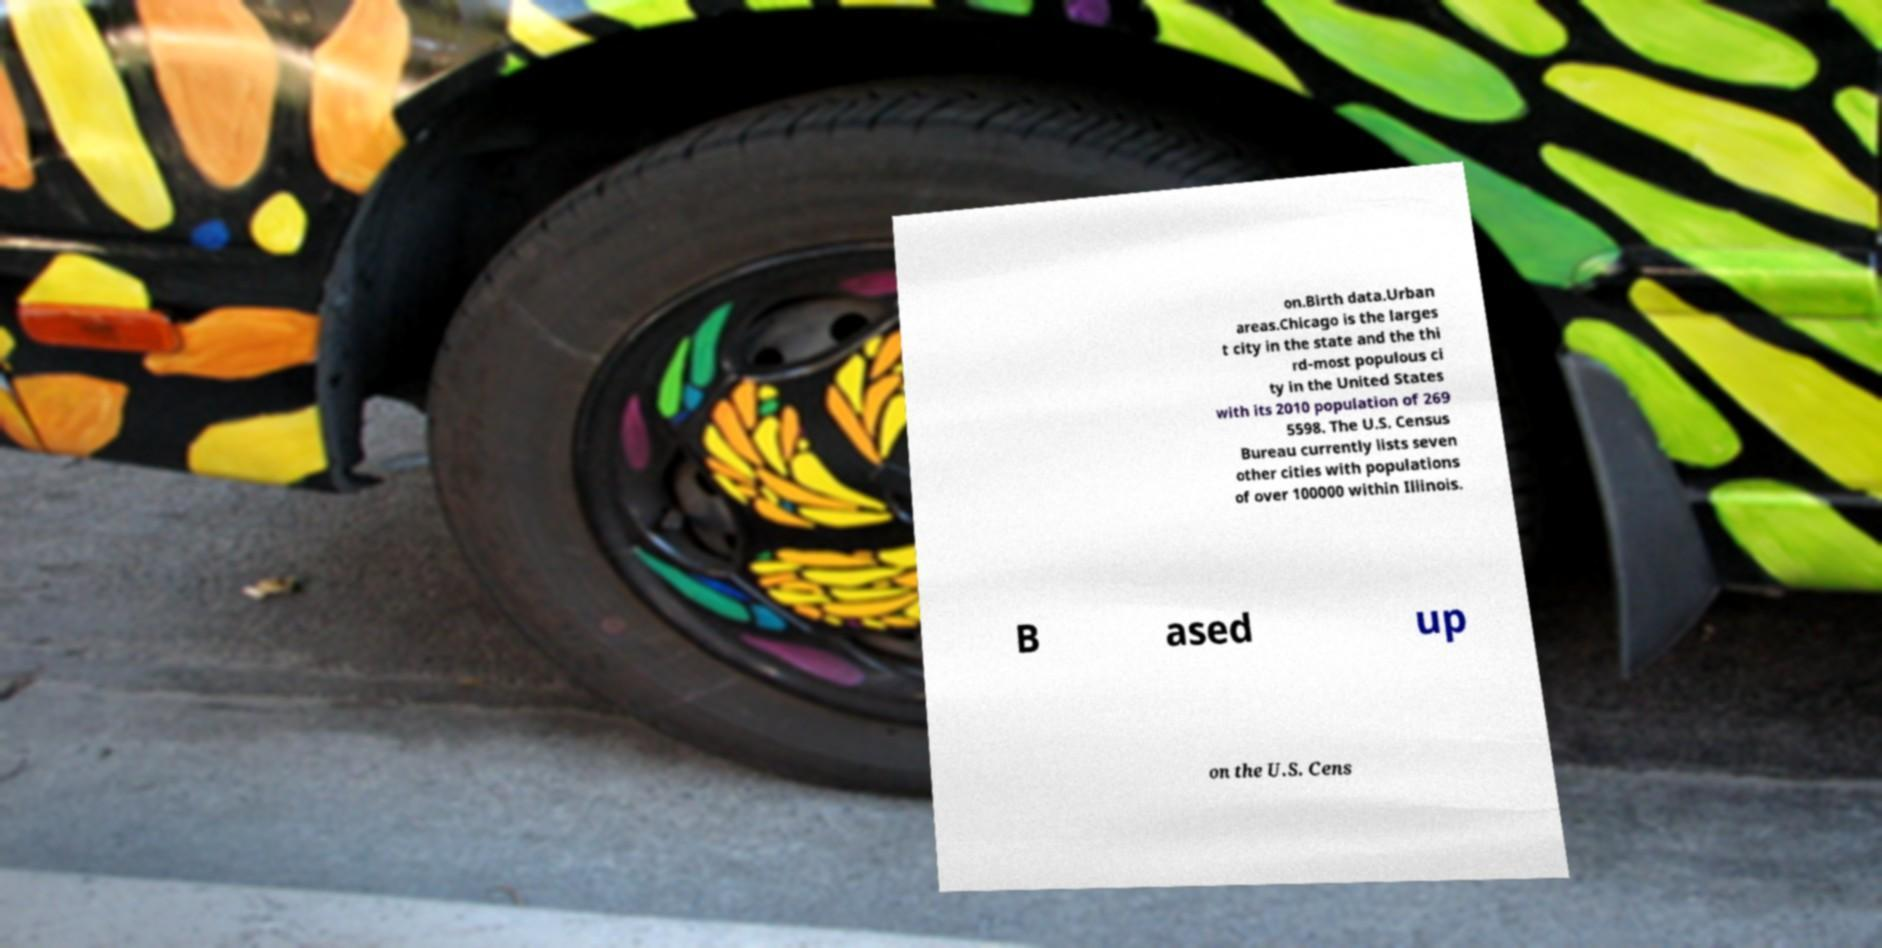Please read and relay the text visible in this image. What does it say? on.Birth data.Urban areas.Chicago is the larges t city in the state and the thi rd-most populous ci ty in the United States with its 2010 population of 269 5598. The U.S. Census Bureau currently lists seven other cities with populations of over 100000 within Illinois. B ased up on the U.S. Cens 